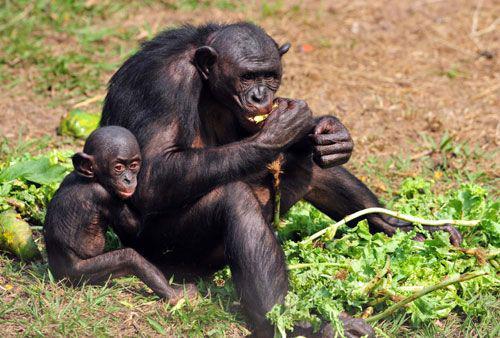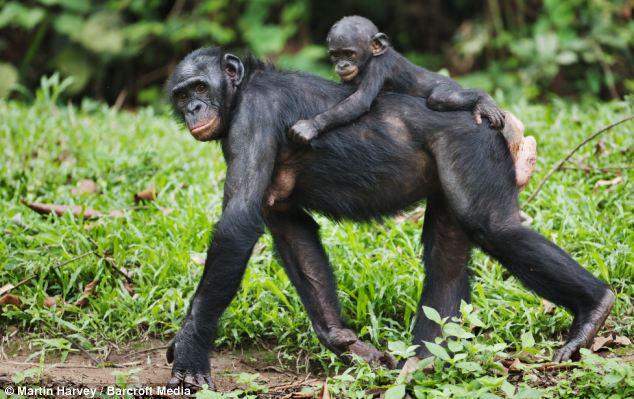The first image is the image on the left, the second image is the image on the right. Assess this claim about the two images: "An image shows just one baby chimp riding on its mother's back.". Correct or not? Answer yes or no. Yes. 